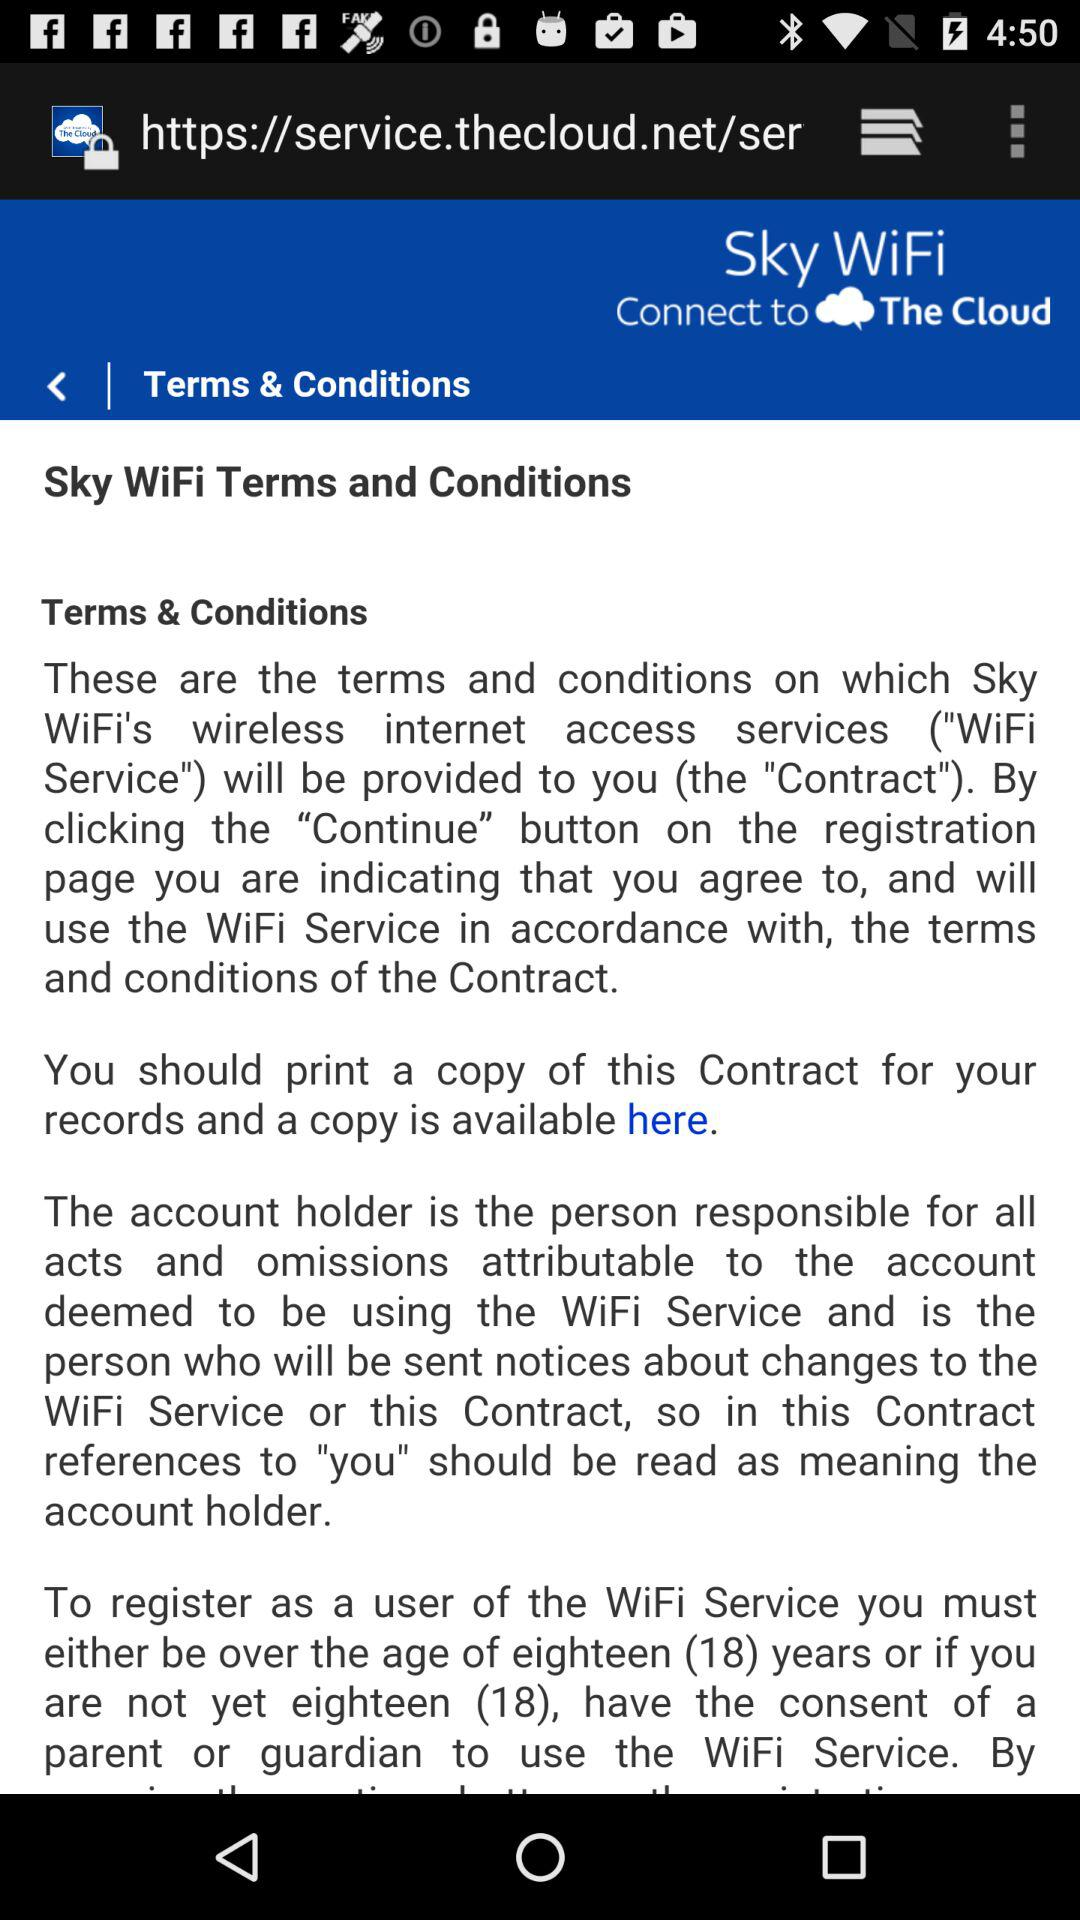What is the wifi name?
When the provided information is insufficient, respond with <no answer>. <no answer> 